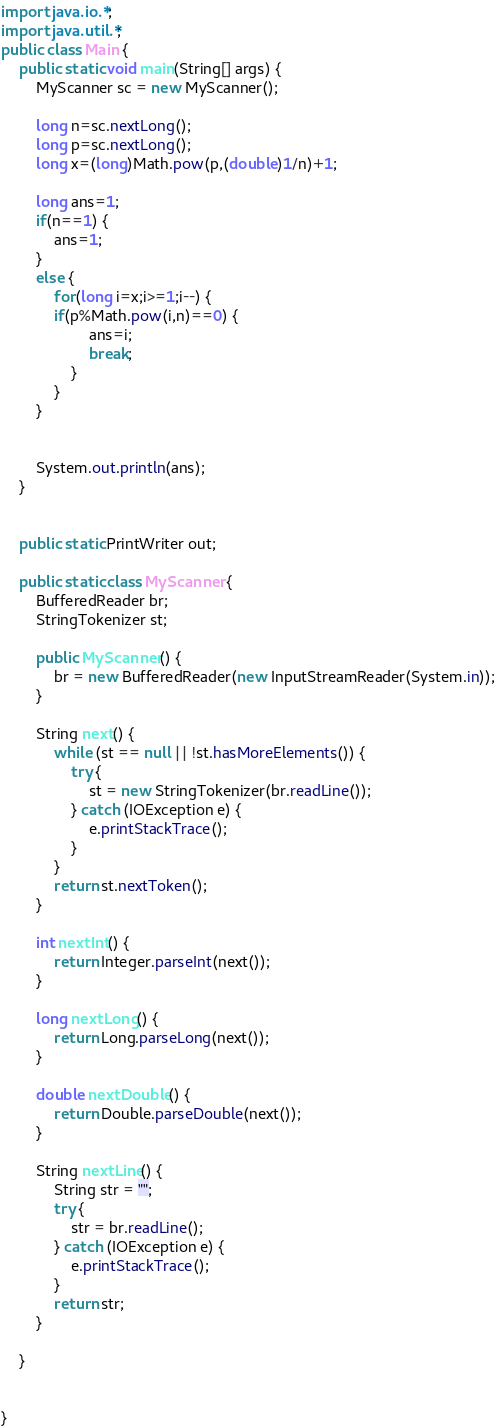<code> <loc_0><loc_0><loc_500><loc_500><_Java_>import java.io.*;
import java.util.*;
public class Main {
	public static void main(String[] args) {
		MyScanner sc = new MyScanner();
		
		long n=sc.nextLong();
		long p=sc.nextLong();
		long x=(long)Math.pow(p,(double)1/n)+1;
		
		long ans=1;
		if(n==1) {
			ans=1;
		}
		else {
			for(long i=x;i>=1;i--) {
			if(p%Math.pow(i,n)==0) {
					ans=i;
					break;
				}
			}
		}
	
		
		System.out.println(ans);
	}
		
	
	public static PrintWriter out;

	public static class MyScanner {
		BufferedReader br;
		StringTokenizer st;

		public MyScanner() {
			br = new BufferedReader(new InputStreamReader(System.in));
		}

		String next() {
			while (st == null || !st.hasMoreElements()) {
				try {
					st = new StringTokenizer(br.readLine());
				} catch (IOException e) {
					e.printStackTrace();
				}
			}
			return st.nextToken();
		}

		int nextInt() {
			return Integer.parseInt(next());
		}

		long nextLong() {
			return Long.parseLong(next());
		}

		double nextDouble() {
			return Double.parseDouble(next());
		}

		String nextLine() {
			String str = "";
			try {
				str = br.readLine();
			} catch (IOException e) {
				e.printStackTrace();
			}
			return str;
		}

	}
	

}



</code> 